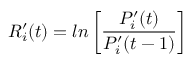Convert formula to latex. <formula><loc_0><loc_0><loc_500><loc_500>R _ { i } ^ { \prime } ( t ) = \ln \left [ \frac { P _ { i } ^ { \prime } ( t ) } { P _ { i } ^ { \prime } ( t - 1 ) } \right ]</formula> 